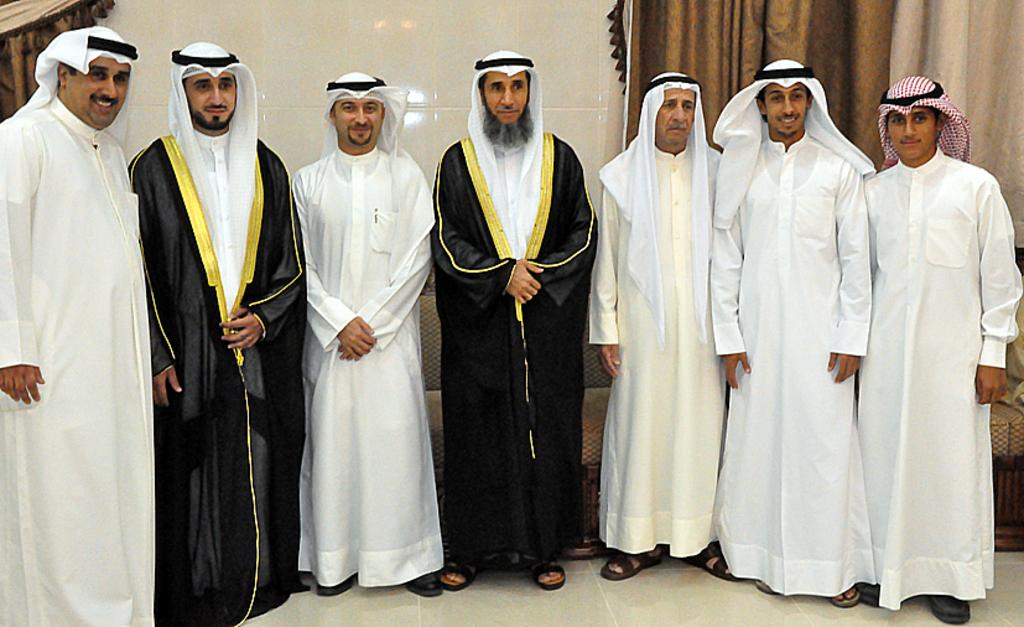What are the people in the image doing? The people in the image are standing. Where are the people standing in the image? The people are standing on the floor. What can be seen in the background of the image? There is a wall visible in the image. What type of furniture is present in the image? There is a couch in the image. What type of window treatment is visible in the image? There are curtains in the image. What type of meat is being transported by the grape in the image? There is no grape or meat present in the image. 